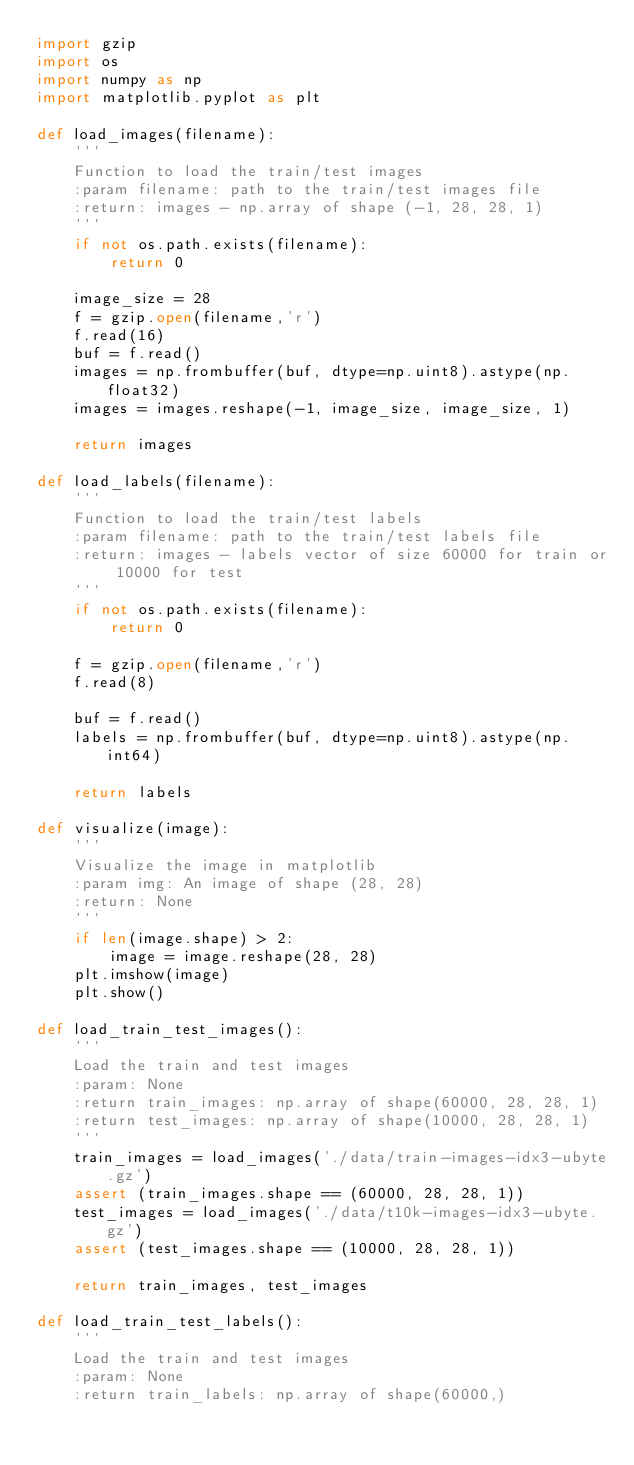Convert code to text. <code><loc_0><loc_0><loc_500><loc_500><_Python_>import gzip
import os
import numpy as np
import matplotlib.pyplot as plt

def load_images(filename):
    '''
    Function to load the train/test images
    :param filename: path to the train/test images file
    :return: images - np.array of shape (-1, 28, 28, 1)
    '''
    if not os.path.exists(filename):
        return 0

    image_size = 28
    f = gzip.open(filename,'r')
    f.read(16)
    buf = f.read()
    images = np.frombuffer(buf, dtype=np.uint8).astype(np.float32)
    images = images.reshape(-1, image_size, image_size, 1)

    return images

def load_labels(filename):
    '''
    Function to load the train/test labels
    :param filename: path to the train/test labels file
    :return: images - labels vector of size 60000 for train or 10000 for test
    '''
    if not os.path.exists(filename):
        return 0

    f = gzip.open(filename,'r')
    f.read(8)

    buf = f.read()
    labels = np.frombuffer(buf, dtype=np.uint8).astype(np.int64)

    return labels

def visualize(image):
    '''
    Visualize the image in matplotlib
    :param img: An image of shape (28, 28)
    :return: None
    '''
    if len(image.shape) > 2:
        image = image.reshape(28, 28)
    plt.imshow(image)
    plt.show()

def load_train_test_images():
    '''
    Load the train and test images
    :param: None
    :return train_images: np.array of shape(60000, 28, 28, 1)
    :return test_images: np.array of shape(10000, 28, 28, 1)
    '''
    train_images = load_images('./data/train-images-idx3-ubyte.gz')
    assert (train_images.shape == (60000, 28, 28, 1))
    test_images = load_images('./data/t10k-images-idx3-ubyte.gz')
    assert (test_images.shape == (10000, 28, 28, 1))

    return train_images, test_images

def load_train_test_labels():
    '''
    Load the train and test images
    :param: None
    :return train_labels: np.array of shape(60000,)</code> 